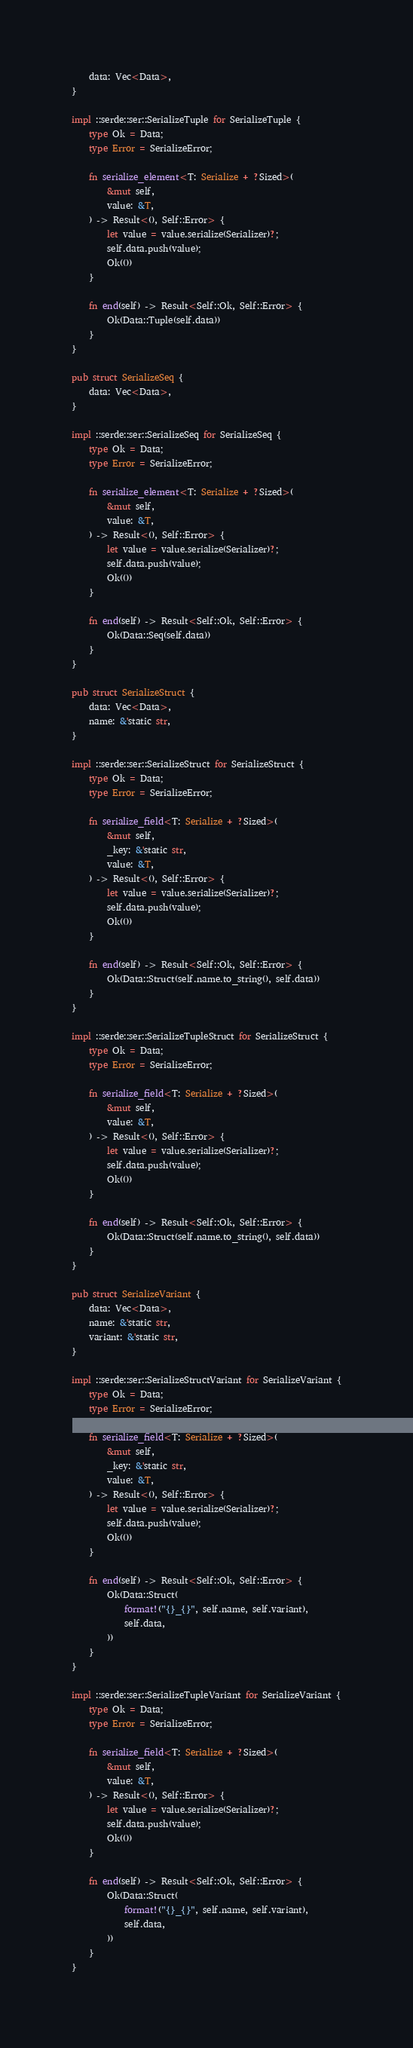Convert code to text. <code><loc_0><loc_0><loc_500><loc_500><_Rust_>    data: Vec<Data>,
}

impl ::serde::ser::SerializeTuple for SerializeTuple {
    type Ok = Data;
    type Error = SerializeError;

    fn serialize_element<T: Serialize + ?Sized>(
        &mut self,
        value: &T,
    ) -> Result<(), Self::Error> {
        let value = value.serialize(Serializer)?;
        self.data.push(value);
        Ok(())
    }

    fn end(self) -> Result<Self::Ok, Self::Error> {
        Ok(Data::Tuple(self.data))
    }
}

pub struct SerializeSeq {
    data: Vec<Data>,
}

impl ::serde::ser::SerializeSeq for SerializeSeq {
    type Ok = Data;
    type Error = SerializeError;

    fn serialize_element<T: Serialize + ?Sized>(
        &mut self,
        value: &T,
    ) -> Result<(), Self::Error> {
        let value = value.serialize(Serializer)?;
        self.data.push(value);
        Ok(())
    }

    fn end(self) -> Result<Self::Ok, Self::Error> {
        Ok(Data::Seq(self.data))
    }
}

pub struct SerializeStruct {
    data: Vec<Data>,
    name: &'static str,
}

impl ::serde::ser::SerializeStruct for SerializeStruct {
    type Ok = Data;
    type Error = SerializeError;

    fn serialize_field<T: Serialize + ?Sized>(
        &mut self,
        _key: &'static str,
        value: &T,
    ) -> Result<(), Self::Error> {
        let value = value.serialize(Serializer)?;
        self.data.push(value);
        Ok(())
    }

    fn end(self) -> Result<Self::Ok, Self::Error> {
        Ok(Data::Struct(self.name.to_string(), self.data))
    }
}

impl ::serde::ser::SerializeTupleStruct for SerializeStruct {
    type Ok = Data;
    type Error = SerializeError;

    fn serialize_field<T: Serialize + ?Sized>(
        &mut self,
        value: &T,
    ) -> Result<(), Self::Error> {
        let value = value.serialize(Serializer)?;
        self.data.push(value);
        Ok(())
    }

    fn end(self) -> Result<Self::Ok, Self::Error> {
        Ok(Data::Struct(self.name.to_string(), self.data))
    }
}

pub struct SerializeVariant {
    data: Vec<Data>,
    name: &'static str,
    variant: &'static str,
}

impl ::serde::ser::SerializeStructVariant for SerializeVariant {
    type Ok = Data;
    type Error = SerializeError;

    fn serialize_field<T: Serialize + ?Sized>(
        &mut self,
        _key: &'static str,
        value: &T,
    ) -> Result<(), Self::Error> {
        let value = value.serialize(Serializer)?;
        self.data.push(value);
        Ok(())
    }

    fn end(self) -> Result<Self::Ok, Self::Error> {
        Ok(Data::Struct(
            format!("{}_{}", self.name, self.variant),
            self.data,
        ))
    }
}

impl ::serde::ser::SerializeTupleVariant for SerializeVariant {
    type Ok = Data;
    type Error = SerializeError;

    fn serialize_field<T: Serialize + ?Sized>(
        &mut self,
        value: &T,
    ) -> Result<(), Self::Error> {
        let value = value.serialize(Serializer)?;
        self.data.push(value);
        Ok(())
    }

    fn end(self) -> Result<Self::Ok, Self::Error> {
        Ok(Data::Struct(
            format!("{}_{}", self.name, self.variant),
            self.data,
        ))
    }
}
</code> 